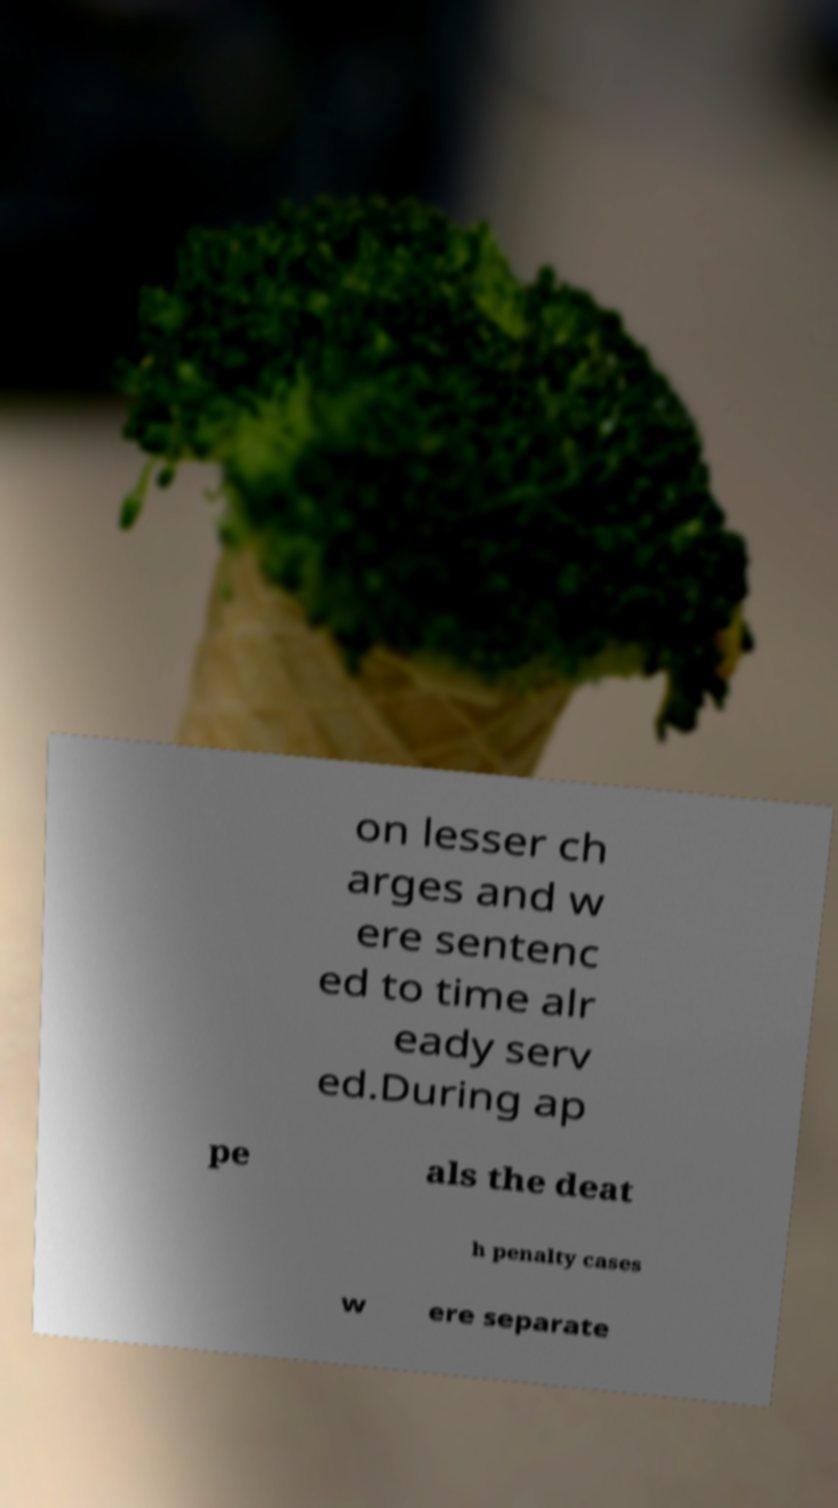What messages or text are displayed in this image? I need them in a readable, typed format. on lesser ch arges and w ere sentenc ed to time alr eady serv ed.During ap pe als the deat h penalty cases w ere separate 